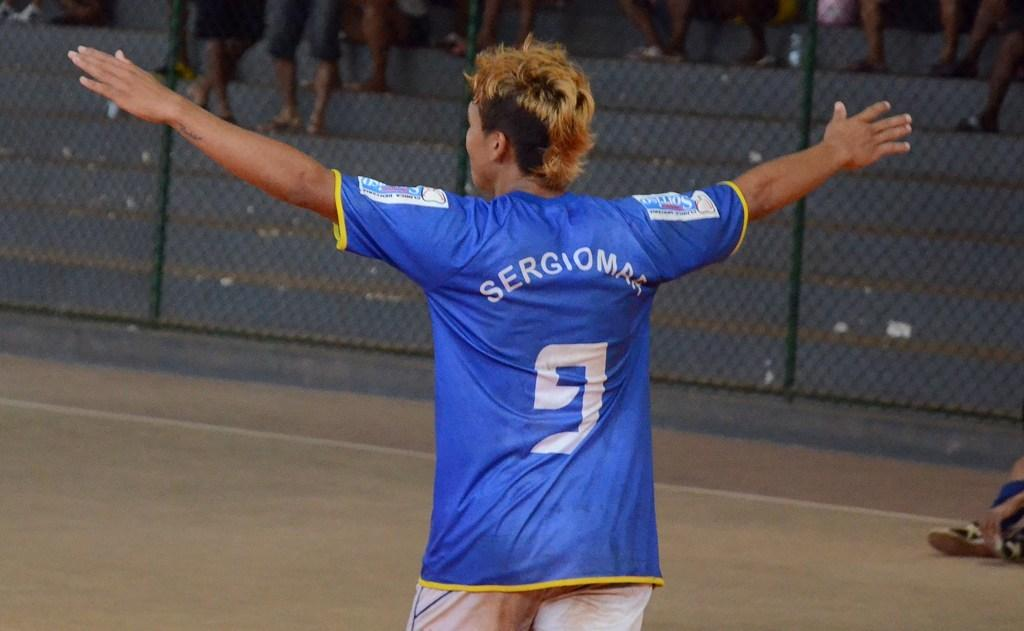<image>
Share a concise interpretation of the image provided. a person with a blue jersey and the number 9 